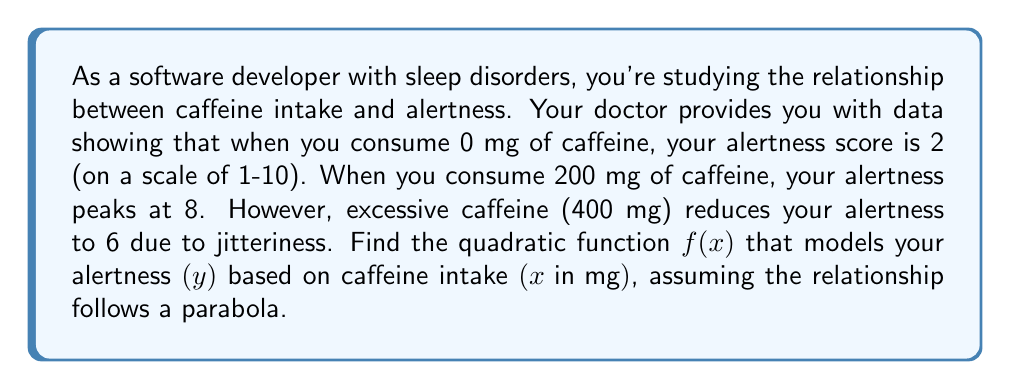Solve this math problem. To find the quadratic function $f(x) = ax^2 + bx + c$, we'll use the given points:
(0, 2), (200, 8), and (400, 6)

1) First, let's substitute these points into the general form of a quadratic equation:

   2 = a(0)^2 + b(0) + c
   8 = a(200)^2 + b(200) + c
   6 = a(400)^2 + b(400) + c

2) From the first equation, we can determine that c = 2

3) Now, let's subtract the first equation from the other two:

   6 = 40000a + 200b
   4 = 160000a + 400b

4) Divide the first equation by 200 and the second by 400:

   0.03 = 200a + b
   0.01 = 400a + b

5) Subtract these equations:

   0.02 = -200a
   a = -0.0001

6) Substitute this value of a back into one of the equations from step 4:

   0.03 = 200(-0.0001) + b
   0.03 = -0.02 + b
   b = 0.05

7) Now we have a, b, and c. The quadratic function is:

   $f(x) = -0.0001x^2 + 0.05x + 2$
Answer: $f(x) = -0.0001x^2 + 0.05x + 2$ 